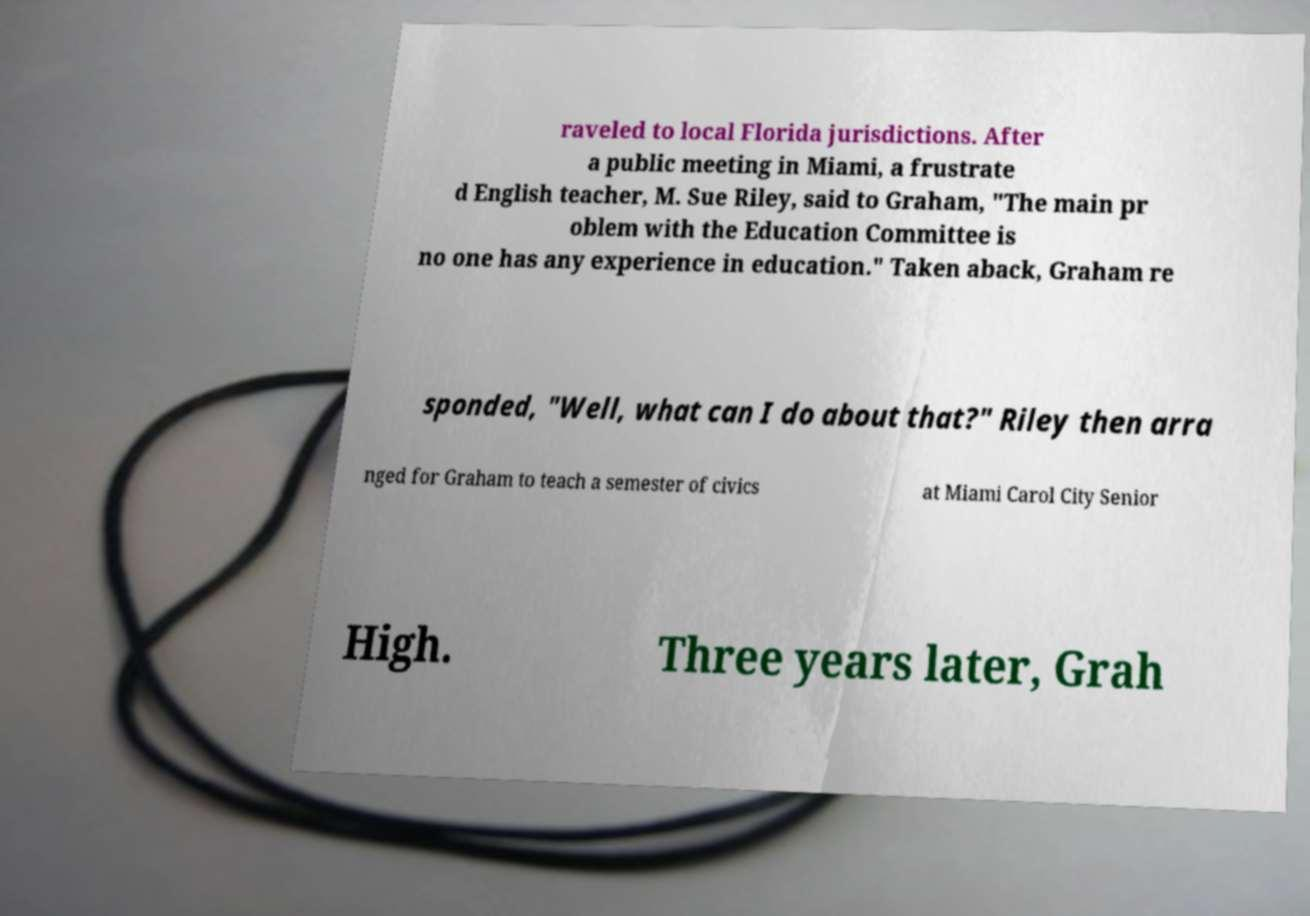Can you read and provide the text displayed in the image?This photo seems to have some interesting text. Can you extract and type it out for me? raveled to local Florida jurisdictions. After a public meeting in Miami, a frustrate d English teacher, M. Sue Riley, said to Graham, "The main pr oblem with the Education Committee is no one has any experience in education." Taken aback, Graham re sponded, "Well, what can I do about that?" Riley then arra nged for Graham to teach a semester of civics at Miami Carol City Senior High. Three years later, Grah 